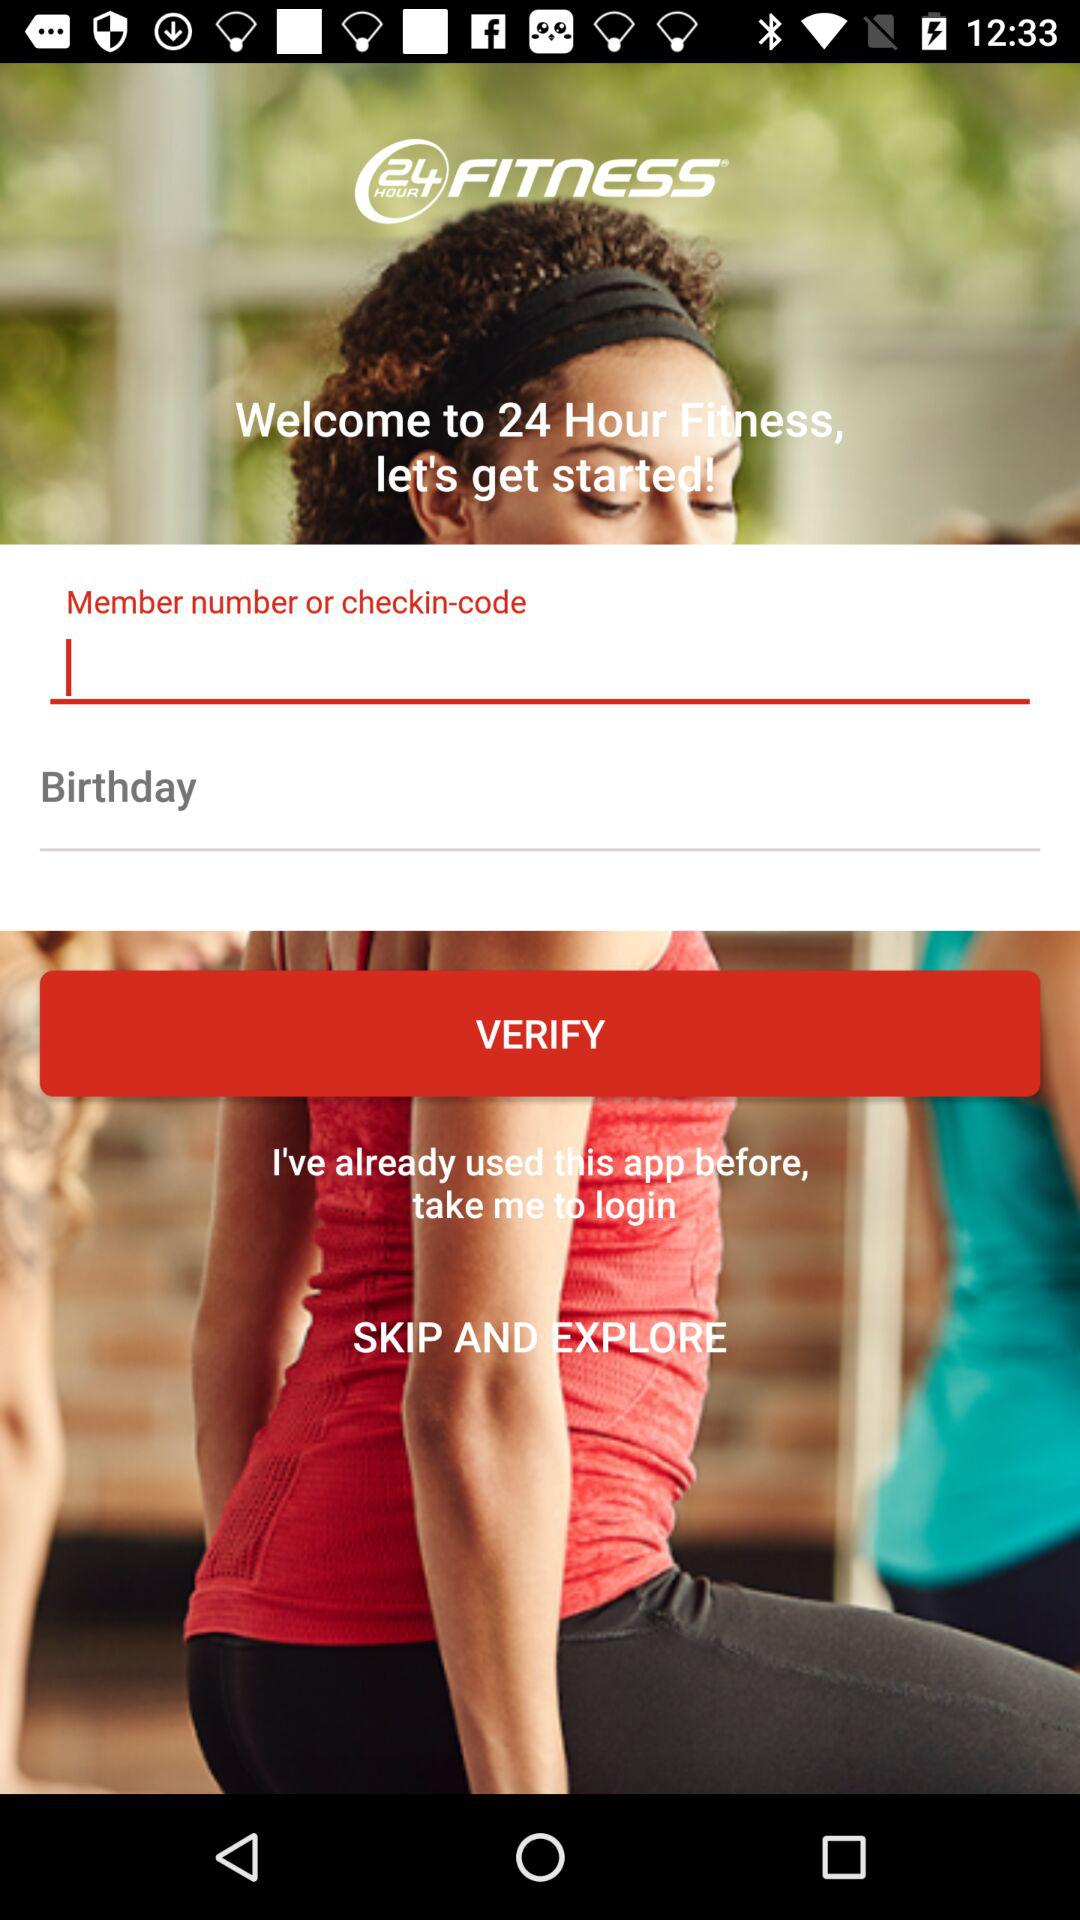What is the name of the application? The name of the application is "24 Hour Fitness". 